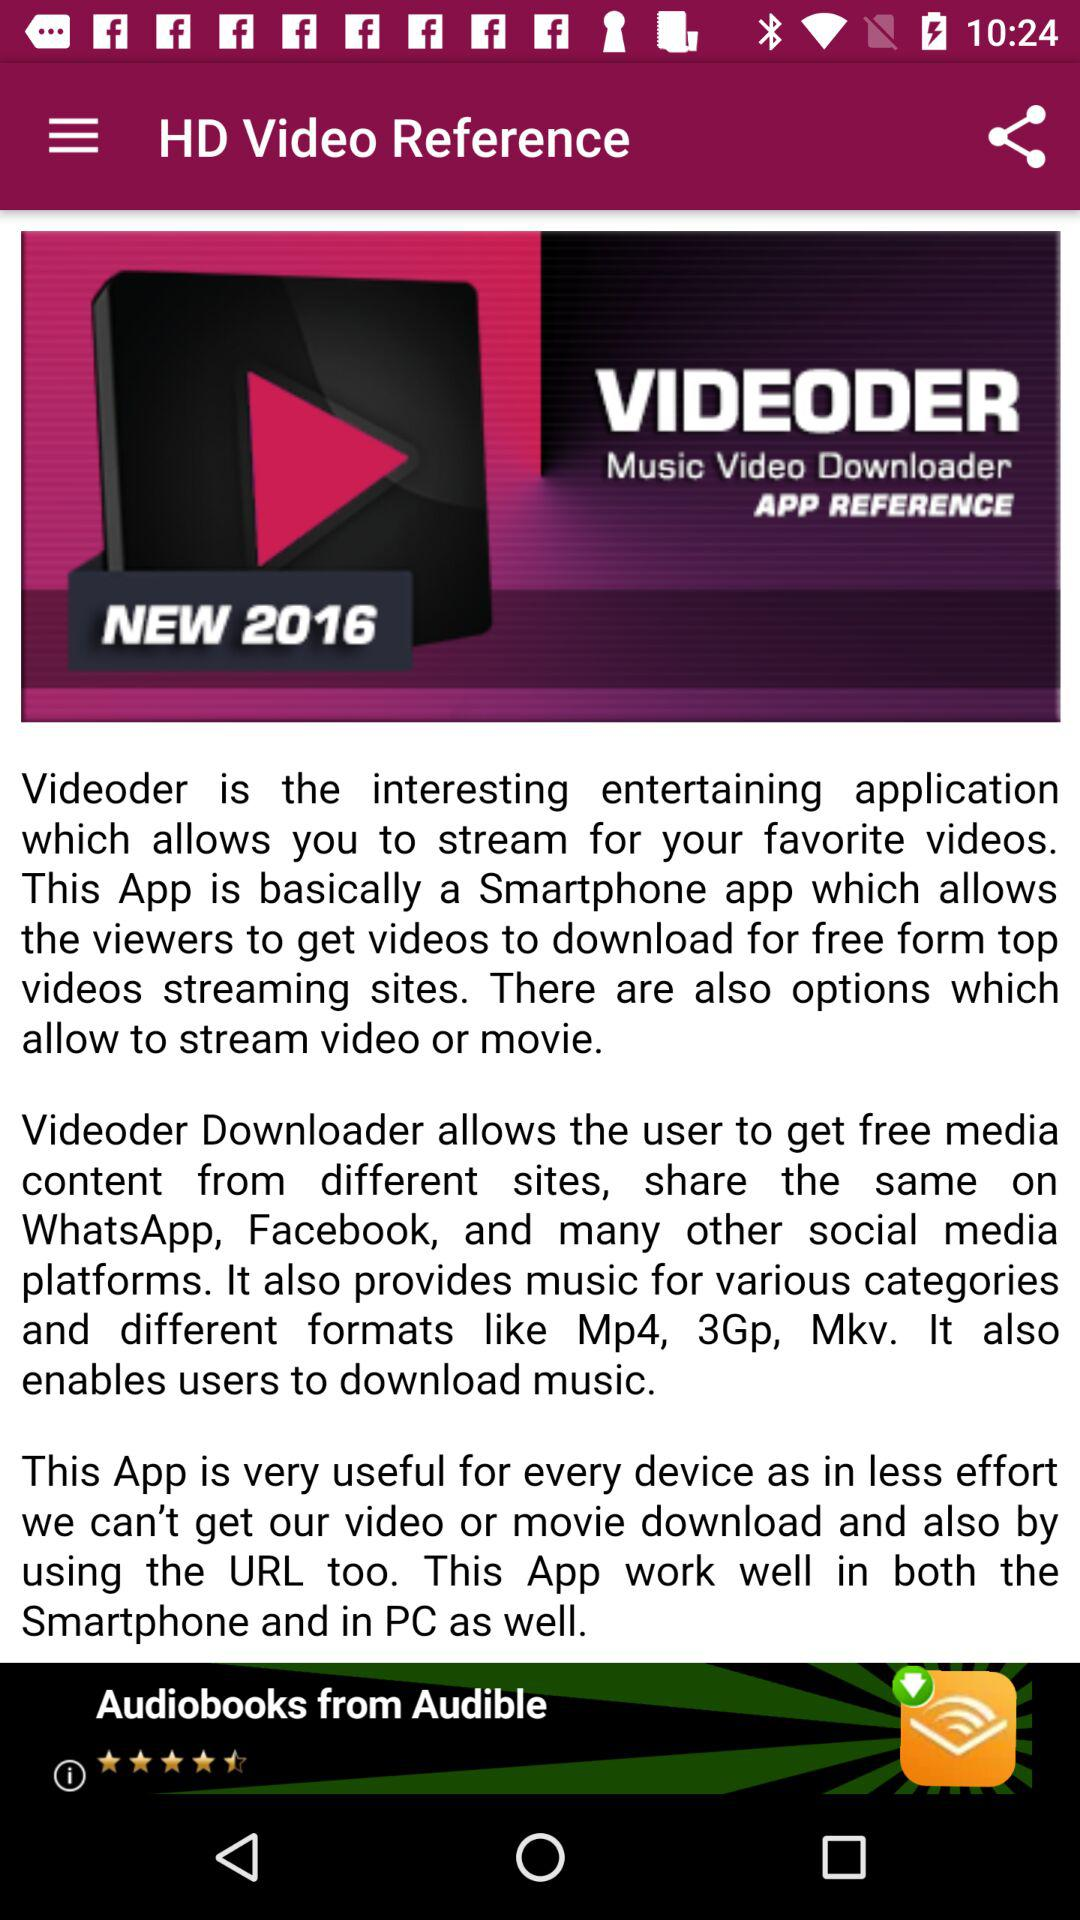What is the application name? The application name is "VIDEODER". 